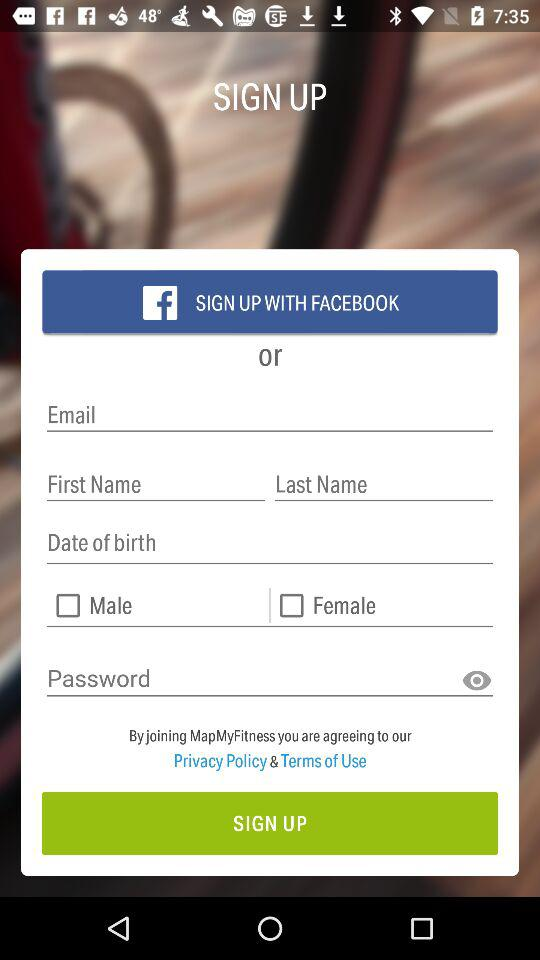How many text inputs are there for email, first name, and last name?
Answer the question using a single word or phrase. 3 